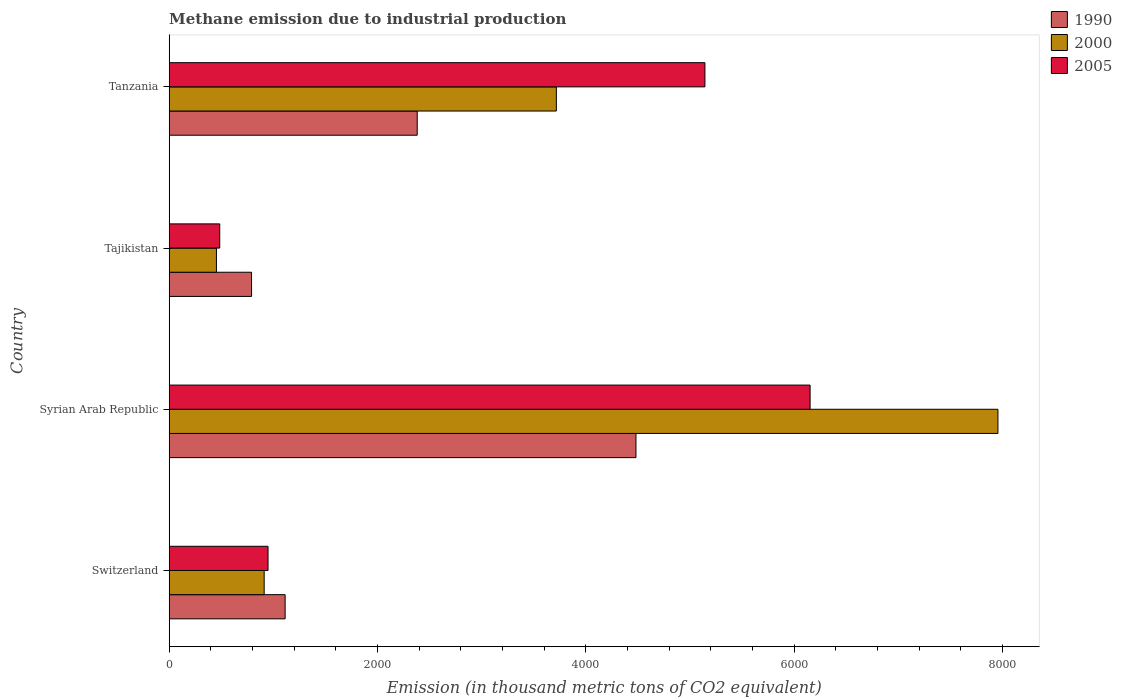How many different coloured bars are there?
Offer a very short reply. 3. How many groups of bars are there?
Your response must be concise. 4. Are the number of bars per tick equal to the number of legend labels?
Give a very brief answer. Yes. How many bars are there on the 1st tick from the top?
Your response must be concise. 3. What is the label of the 4th group of bars from the top?
Provide a short and direct response. Switzerland. In how many cases, is the number of bars for a given country not equal to the number of legend labels?
Your answer should be compact. 0. What is the amount of methane emitted in 2000 in Switzerland?
Provide a succinct answer. 911.6. Across all countries, what is the maximum amount of methane emitted in 1990?
Your answer should be very brief. 4480.2. Across all countries, what is the minimum amount of methane emitted in 1990?
Make the answer very short. 790.4. In which country was the amount of methane emitted in 2000 maximum?
Provide a succinct answer. Syrian Arab Republic. In which country was the amount of methane emitted in 2000 minimum?
Your answer should be very brief. Tajikistan. What is the total amount of methane emitted in 2000 in the graph?
Make the answer very short. 1.30e+04. What is the difference between the amount of methane emitted in 1990 in Syrian Arab Republic and that in Tajikistan?
Give a very brief answer. 3689.8. What is the difference between the amount of methane emitted in 2000 in Switzerland and the amount of methane emitted in 1990 in Tajikistan?
Make the answer very short. 121.2. What is the average amount of methane emitted in 1990 per country?
Ensure brevity in your answer.  2190.97. What is the difference between the amount of methane emitted in 1990 and amount of methane emitted in 2000 in Switzerland?
Give a very brief answer. 201.1. What is the ratio of the amount of methane emitted in 2005 in Syrian Arab Republic to that in Tanzania?
Offer a terse response. 1.2. Is the amount of methane emitted in 1990 in Syrian Arab Republic less than that in Tajikistan?
Keep it short and to the point. No. What is the difference between the highest and the second highest amount of methane emitted in 2005?
Your answer should be compact. 1009.5. What is the difference between the highest and the lowest amount of methane emitted in 1990?
Keep it short and to the point. 3689.8. In how many countries, is the amount of methane emitted in 2005 greater than the average amount of methane emitted in 2005 taken over all countries?
Offer a terse response. 2. Is the sum of the amount of methane emitted in 2005 in Switzerland and Tajikistan greater than the maximum amount of methane emitted in 1990 across all countries?
Your response must be concise. No. What does the 3rd bar from the top in Tajikistan represents?
Offer a terse response. 1990. Is it the case that in every country, the sum of the amount of methane emitted in 1990 and amount of methane emitted in 2005 is greater than the amount of methane emitted in 2000?
Make the answer very short. Yes. How many bars are there?
Give a very brief answer. 12. Are all the bars in the graph horizontal?
Offer a terse response. Yes. How many countries are there in the graph?
Keep it short and to the point. 4. What is the difference between two consecutive major ticks on the X-axis?
Ensure brevity in your answer.  2000. Are the values on the major ticks of X-axis written in scientific E-notation?
Keep it short and to the point. No. What is the title of the graph?
Provide a succinct answer. Methane emission due to industrial production. What is the label or title of the X-axis?
Make the answer very short. Emission (in thousand metric tons of CO2 equivalent). What is the Emission (in thousand metric tons of CO2 equivalent) of 1990 in Switzerland?
Offer a terse response. 1112.7. What is the Emission (in thousand metric tons of CO2 equivalent) of 2000 in Switzerland?
Your answer should be compact. 911.6. What is the Emission (in thousand metric tons of CO2 equivalent) of 2005 in Switzerland?
Make the answer very short. 948.6. What is the Emission (in thousand metric tons of CO2 equivalent) of 1990 in Syrian Arab Republic?
Make the answer very short. 4480.2. What is the Emission (in thousand metric tons of CO2 equivalent) in 2000 in Syrian Arab Republic?
Give a very brief answer. 7954.6. What is the Emission (in thousand metric tons of CO2 equivalent) of 2005 in Syrian Arab Republic?
Provide a short and direct response. 6151.7. What is the Emission (in thousand metric tons of CO2 equivalent) in 1990 in Tajikistan?
Provide a short and direct response. 790.4. What is the Emission (in thousand metric tons of CO2 equivalent) in 2000 in Tajikistan?
Your answer should be compact. 453.3. What is the Emission (in thousand metric tons of CO2 equivalent) in 2005 in Tajikistan?
Your answer should be compact. 485. What is the Emission (in thousand metric tons of CO2 equivalent) in 1990 in Tanzania?
Provide a short and direct response. 2380.6. What is the Emission (in thousand metric tons of CO2 equivalent) of 2000 in Tanzania?
Provide a succinct answer. 3716.1. What is the Emission (in thousand metric tons of CO2 equivalent) in 2005 in Tanzania?
Your response must be concise. 5142.2. Across all countries, what is the maximum Emission (in thousand metric tons of CO2 equivalent) of 1990?
Offer a terse response. 4480.2. Across all countries, what is the maximum Emission (in thousand metric tons of CO2 equivalent) in 2000?
Offer a very short reply. 7954.6. Across all countries, what is the maximum Emission (in thousand metric tons of CO2 equivalent) of 2005?
Provide a succinct answer. 6151.7. Across all countries, what is the minimum Emission (in thousand metric tons of CO2 equivalent) in 1990?
Provide a succinct answer. 790.4. Across all countries, what is the minimum Emission (in thousand metric tons of CO2 equivalent) in 2000?
Offer a very short reply. 453.3. Across all countries, what is the minimum Emission (in thousand metric tons of CO2 equivalent) in 2005?
Give a very brief answer. 485. What is the total Emission (in thousand metric tons of CO2 equivalent) in 1990 in the graph?
Provide a short and direct response. 8763.9. What is the total Emission (in thousand metric tons of CO2 equivalent) in 2000 in the graph?
Your answer should be compact. 1.30e+04. What is the total Emission (in thousand metric tons of CO2 equivalent) in 2005 in the graph?
Keep it short and to the point. 1.27e+04. What is the difference between the Emission (in thousand metric tons of CO2 equivalent) of 1990 in Switzerland and that in Syrian Arab Republic?
Offer a terse response. -3367.5. What is the difference between the Emission (in thousand metric tons of CO2 equivalent) of 2000 in Switzerland and that in Syrian Arab Republic?
Give a very brief answer. -7043. What is the difference between the Emission (in thousand metric tons of CO2 equivalent) in 2005 in Switzerland and that in Syrian Arab Republic?
Keep it short and to the point. -5203.1. What is the difference between the Emission (in thousand metric tons of CO2 equivalent) in 1990 in Switzerland and that in Tajikistan?
Your response must be concise. 322.3. What is the difference between the Emission (in thousand metric tons of CO2 equivalent) of 2000 in Switzerland and that in Tajikistan?
Your response must be concise. 458.3. What is the difference between the Emission (in thousand metric tons of CO2 equivalent) in 2005 in Switzerland and that in Tajikistan?
Your answer should be very brief. 463.6. What is the difference between the Emission (in thousand metric tons of CO2 equivalent) of 1990 in Switzerland and that in Tanzania?
Offer a terse response. -1267.9. What is the difference between the Emission (in thousand metric tons of CO2 equivalent) of 2000 in Switzerland and that in Tanzania?
Your response must be concise. -2804.5. What is the difference between the Emission (in thousand metric tons of CO2 equivalent) in 2005 in Switzerland and that in Tanzania?
Your answer should be very brief. -4193.6. What is the difference between the Emission (in thousand metric tons of CO2 equivalent) in 1990 in Syrian Arab Republic and that in Tajikistan?
Keep it short and to the point. 3689.8. What is the difference between the Emission (in thousand metric tons of CO2 equivalent) in 2000 in Syrian Arab Republic and that in Tajikistan?
Make the answer very short. 7501.3. What is the difference between the Emission (in thousand metric tons of CO2 equivalent) of 2005 in Syrian Arab Republic and that in Tajikistan?
Provide a short and direct response. 5666.7. What is the difference between the Emission (in thousand metric tons of CO2 equivalent) in 1990 in Syrian Arab Republic and that in Tanzania?
Ensure brevity in your answer.  2099.6. What is the difference between the Emission (in thousand metric tons of CO2 equivalent) of 2000 in Syrian Arab Republic and that in Tanzania?
Provide a succinct answer. 4238.5. What is the difference between the Emission (in thousand metric tons of CO2 equivalent) of 2005 in Syrian Arab Republic and that in Tanzania?
Your answer should be very brief. 1009.5. What is the difference between the Emission (in thousand metric tons of CO2 equivalent) of 1990 in Tajikistan and that in Tanzania?
Give a very brief answer. -1590.2. What is the difference between the Emission (in thousand metric tons of CO2 equivalent) in 2000 in Tajikistan and that in Tanzania?
Your response must be concise. -3262.8. What is the difference between the Emission (in thousand metric tons of CO2 equivalent) of 2005 in Tajikistan and that in Tanzania?
Provide a succinct answer. -4657.2. What is the difference between the Emission (in thousand metric tons of CO2 equivalent) of 1990 in Switzerland and the Emission (in thousand metric tons of CO2 equivalent) of 2000 in Syrian Arab Republic?
Give a very brief answer. -6841.9. What is the difference between the Emission (in thousand metric tons of CO2 equivalent) of 1990 in Switzerland and the Emission (in thousand metric tons of CO2 equivalent) of 2005 in Syrian Arab Republic?
Your response must be concise. -5039. What is the difference between the Emission (in thousand metric tons of CO2 equivalent) of 2000 in Switzerland and the Emission (in thousand metric tons of CO2 equivalent) of 2005 in Syrian Arab Republic?
Give a very brief answer. -5240.1. What is the difference between the Emission (in thousand metric tons of CO2 equivalent) in 1990 in Switzerland and the Emission (in thousand metric tons of CO2 equivalent) in 2000 in Tajikistan?
Provide a short and direct response. 659.4. What is the difference between the Emission (in thousand metric tons of CO2 equivalent) of 1990 in Switzerland and the Emission (in thousand metric tons of CO2 equivalent) of 2005 in Tajikistan?
Ensure brevity in your answer.  627.7. What is the difference between the Emission (in thousand metric tons of CO2 equivalent) of 2000 in Switzerland and the Emission (in thousand metric tons of CO2 equivalent) of 2005 in Tajikistan?
Give a very brief answer. 426.6. What is the difference between the Emission (in thousand metric tons of CO2 equivalent) of 1990 in Switzerland and the Emission (in thousand metric tons of CO2 equivalent) of 2000 in Tanzania?
Your answer should be compact. -2603.4. What is the difference between the Emission (in thousand metric tons of CO2 equivalent) of 1990 in Switzerland and the Emission (in thousand metric tons of CO2 equivalent) of 2005 in Tanzania?
Offer a very short reply. -4029.5. What is the difference between the Emission (in thousand metric tons of CO2 equivalent) of 2000 in Switzerland and the Emission (in thousand metric tons of CO2 equivalent) of 2005 in Tanzania?
Your answer should be compact. -4230.6. What is the difference between the Emission (in thousand metric tons of CO2 equivalent) of 1990 in Syrian Arab Republic and the Emission (in thousand metric tons of CO2 equivalent) of 2000 in Tajikistan?
Make the answer very short. 4026.9. What is the difference between the Emission (in thousand metric tons of CO2 equivalent) in 1990 in Syrian Arab Republic and the Emission (in thousand metric tons of CO2 equivalent) in 2005 in Tajikistan?
Your answer should be compact. 3995.2. What is the difference between the Emission (in thousand metric tons of CO2 equivalent) of 2000 in Syrian Arab Republic and the Emission (in thousand metric tons of CO2 equivalent) of 2005 in Tajikistan?
Give a very brief answer. 7469.6. What is the difference between the Emission (in thousand metric tons of CO2 equivalent) in 1990 in Syrian Arab Republic and the Emission (in thousand metric tons of CO2 equivalent) in 2000 in Tanzania?
Your response must be concise. 764.1. What is the difference between the Emission (in thousand metric tons of CO2 equivalent) of 1990 in Syrian Arab Republic and the Emission (in thousand metric tons of CO2 equivalent) of 2005 in Tanzania?
Make the answer very short. -662. What is the difference between the Emission (in thousand metric tons of CO2 equivalent) in 2000 in Syrian Arab Republic and the Emission (in thousand metric tons of CO2 equivalent) in 2005 in Tanzania?
Give a very brief answer. 2812.4. What is the difference between the Emission (in thousand metric tons of CO2 equivalent) in 1990 in Tajikistan and the Emission (in thousand metric tons of CO2 equivalent) in 2000 in Tanzania?
Give a very brief answer. -2925.7. What is the difference between the Emission (in thousand metric tons of CO2 equivalent) in 1990 in Tajikistan and the Emission (in thousand metric tons of CO2 equivalent) in 2005 in Tanzania?
Ensure brevity in your answer.  -4351.8. What is the difference between the Emission (in thousand metric tons of CO2 equivalent) of 2000 in Tajikistan and the Emission (in thousand metric tons of CO2 equivalent) of 2005 in Tanzania?
Give a very brief answer. -4688.9. What is the average Emission (in thousand metric tons of CO2 equivalent) of 1990 per country?
Your response must be concise. 2190.97. What is the average Emission (in thousand metric tons of CO2 equivalent) of 2000 per country?
Provide a short and direct response. 3258.9. What is the average Emission (in thousand metric tons of CO2 equivalent) of 2005 per country?
Offer a terse response. 3181.88. What is the difference between the Emission (in thousand metric tons of CO2 equivalent) of 1990 and Emission (in thousand metric tons of CO2 equivalent) of 2000 in Switzerland?
Offer a terse response. 201.1. What is the difference between the Emission (in thousand metric tons of CO2 equivalent) in 1990 and Emission (in thousand metric tons of CO2 equivalent) in 2005 in Switzerland?
Your response must be concise. 164.1. What is the difference between the Emission (in thousand metric tons of CO2 equivalent) of 2000 and Emission (in thousand metric tons of CO2 equivalent) of 2005 in Switzerland?
Offer a terse response. -37. What is the difference between the Emission (in thousand metric tons of CO2 equivalent) in 1990 and Emission (in thousand metric tons of CO2 equivalent) in 2000 in Syrian Arab Republic?
Make the answer very short. -3474.4. What is the difference between the Emission (in thousand metric tons of CO2 equivalent) of 1990 and Emission (in thousand metric tons of CO2 equivalent) of 2005 in Syrian Arab Republic?
Provide a succinct answer. -1671.5. What is the difference between the Emission (in thousand metric tons of CO2 equivalent) of 2000 and Emission (in thousand metric tons of CO2 equivalent) of 2005 in Syrian Arab Republic?
Provide a succinct answer. 1802.9. What is the difference between the Emission (in thousand metric tons of CO2 equivalent) of 1990 and Emission (in thousand metric tons of CO2 equivalent) of 2000 in Tajikistan?
Your response must be concise. 337.1. What is the difference between the Emission (in thousand metric tons of CO2 equivalent) in 1990 and Emission (in thousand metric tons of CO2 equivalent) in 2005 in Tajikistan?
Your answer should be compact. 305.4. What is the difference between the Emission (in thousand metric tons of CO2 equivalent) of 2000 and Emission (in thousand metric tons of CO2 equivalent) of 2005 in Tajikistan?
Your answer should be compact. -31.7. What is the difference between the Emission (in thousand metric tons of CO2 equivalent) of 1990 and Emission (in thousand metric tons of CO2 equivalent) of 2000 in Tanzania?
Make the answer very short. -1335.5. What is the difference between the Emission (in thousand metric tons of CO2 equivalent) of 1990 and Emission (in thousand metric tons of CO2 equivalent) of 2005 in Tanzania?
Make the answer very short. -2761.6. What is the difference between the Emission (in thousand metric tons of CO2 equivalent) in 2000 and Emission (in thousand metric tons of CO2 equivalent) in 2005 in Tanzania?
Provide a succinct answer. -1426.1. What is the ratio of the Emission (in thousand metric tons of CO2 equivalent) of 1990 in Switzerland to that in Syrian Arab Republic?
Keep it short and to the point. 0.25. What is the ratio of the Emission (in thousand metric tons of CO2 equivalent) in 2000 in Switzerland to that in Syrian Arab Republic?
Make the answer very short. 0.11. What is the ratio of the Emission (in thousand metric tons of CO2 equivalent) in 2005 in Switzerland to that in Syrian Arab Republic?
Your response must be concise. 0.15. What is the ratio of the Emission (in thousand metric tons of CO2 equivalent) of 1990 in Switzerland to that in Tajikistan?
Your response must be concise. 1.41. What is the ratio of the Emission (in thousand metric tons of CO2 equivalent) in 2000 in Switzerland to that in Tajikistan?
Give a very brief answer. 2.01. What is the ratio of the Emission (in thousand metric tons of CO2 equivalent) in 2005 in Switzerland to that in Tajikistan?
Make the answer very short. 1.96. What is the ratio of the Emission (in thousand metric tons of CO2 equivalent) in 1990 in Switzerland to that in Tanzania?
Provide a succinct answer. 0.47. What is the ratio of the Emission (in thousand metric tons of CO2 equivalent) in 2000 in Switzerland to that in Tanzania?
Keep it short and to the point. 0.25. What is the ratio of the Emission (in thousand metric tons of CO2 equivalent) of 2005 in Switzerland to that in Tanzania?
Provide a succinct answer. 0.18. What is the ratio of the Emission (in thousand metric tons of CO2 equivalent) in 1990 in Syrian Arab Republic to that in Tajikistan?
Your answer should be very brief. 5.67. What is the ratio of the Emission (in thousand metric tons of CO2 equivalent) of 2000 in Syrian Arab Republic to that in Tajikistan?
Ensure brevity in your answer.  17.55. What is the ratio of the Emission (in thousand metric tons of CO2 equivalent) of 2005 in Syrian Arab Republic to that in Tajikistan?
Your response must be concise. 12.68. What is the ratio of the Emission (in thousand metric tons of CO2 equivalent) in 1990 in Syrian Arab Republic to that in Tanzania?
Give a very brief answer. 1.88. What is the ratio of the Emission (in thousand metric tons of CO2 equivalent) in 2000 in Syrian Arab Republic to that in Tanzania?
Your answer should be very brief. 2.14. What is the ratio of the Emission (in thousand metric tons of CO2 equivalent) of 2005 in Syrian Arab Republic to that in Tanzania?
Offer a terse response. 1.2. What is the ratio of the Emission (in thousand metric tons of CO2 equivalent) in 1990 in Tajikistan to that in Tanzania?
Provide a short and direct response. 0.33. What is the ratio of the Emission (in thousand metric tons of CO2 equivalent) in 2000 in Tajikistan to that in Tanzania?
Provide a short and direct response. 0.12. What is the ratio of the Emission (in thousand metric tons of CO2 equivalent) in 2005 in Tajikistan to that in Tanzania?
Your response must be concise. 0.09. What is the difference between the highest and the second highest Emission (in thousand metric tons of CO2 equivalent) of 1990?
Provide a succinct answer. 2099.6. What is the difference between the highest and the second highest Emission (in thousand metric tons of CO2 equivalent) in 2000?
Give a very brief answer. 4238.5. What is the difference between the highest and the second highest Emission (in thousand metric tons of CO2 equivalent) in 2005?
Your answer should be very brief. 1009.5. What is the difference between the highest and the lowest Emission (in thousand metric tons of CO2 equivalent) of 1990?
Offer a very short reply. 3689.8. What is the difference between the highest and the lowest Emission (in thousand metric tons of CO2 equivalent) in 2000?
Offer a very short reply. 7501.3. What is the difference between the highest and the lowest Emission (in thousand metric tons of CO2 equivalent) of 2005?
Provide a succinct answer. 5666.7. 